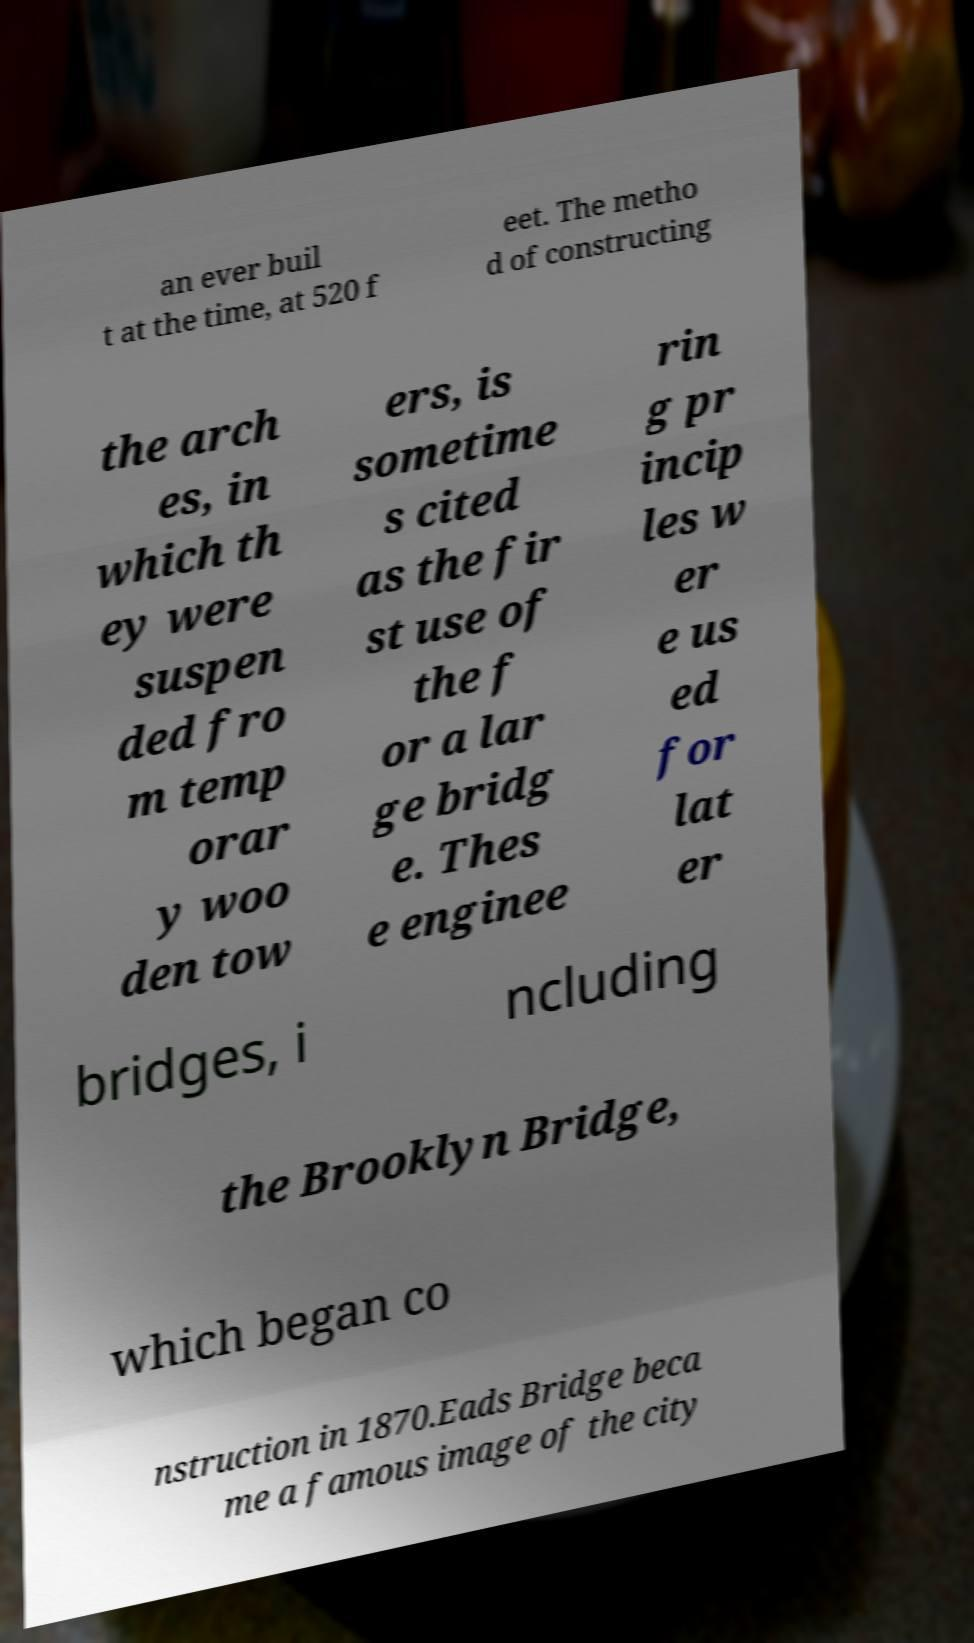I need the written content from this picture converted into text. Can you do that? an ever buil t at the time, at 520 f eet. The metho d of constructing the arch es, in which th ey were suspen ded fro m temp orar y woo den tow ers, is sometime s cited as the fir st use of the f or a lar ge bridg e. Thes e enginee rin g pr incip les w er e us ed for lat er bridges, i ncluding the Brooklyn Bridge, which began co nstruction in 1870.Eads Bridge beca me a famous image of the city 